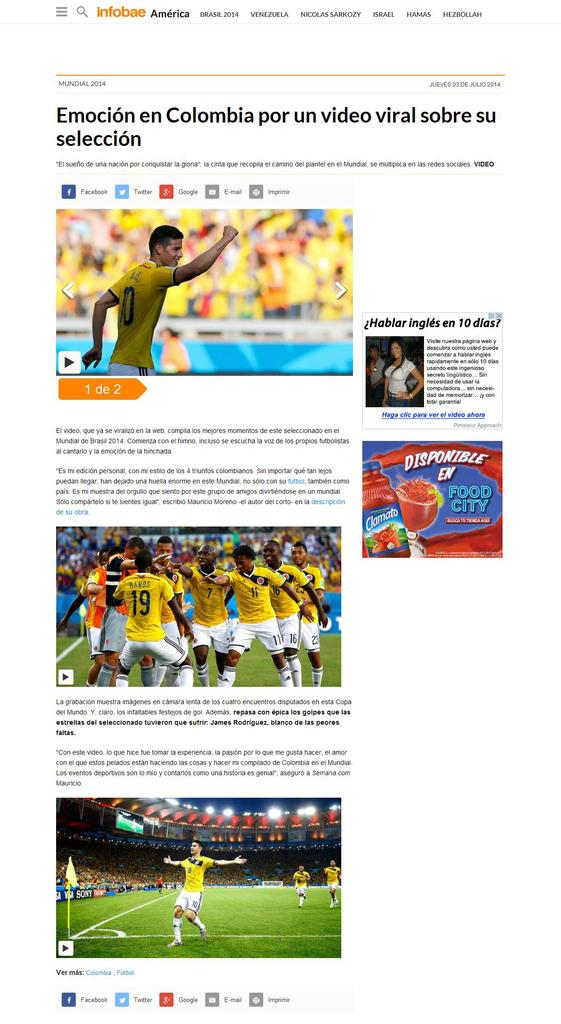<image>
Relay a brief, clear account of the picture shown. A picture of sports games with a headline that begins with the word Emocion. 